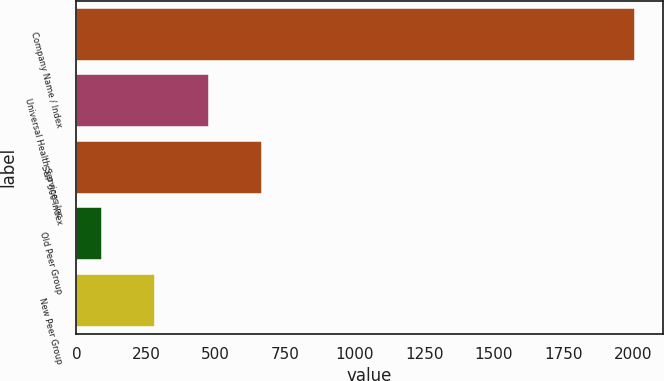<chart> <loc_0><loc_0><loc_500><loc_500><bar_chart><fcel>Company Name / Index<fcel>Universal Health Services Inc<fcel>S&P 500 Index<fcel>Old Peer Group<fcel>New Peer Group<nl><fcel>2006<fcel>475<fcel>666.38<fcel>92.24<fcel>283.62<nl></chart> 